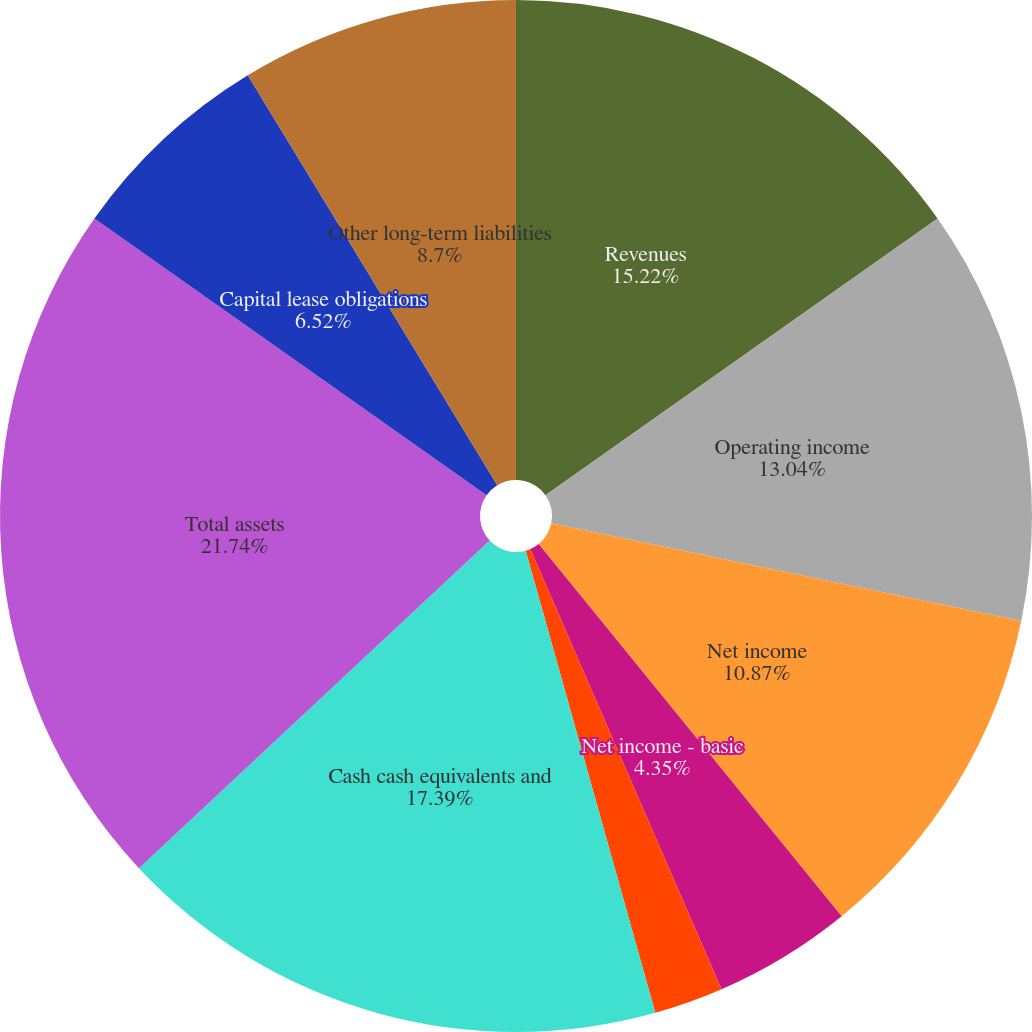Convert chart. <chart><loc_0><loc_0><loc_500><loc_500><pie_chart><fcel>Revenues<fcel>Operating income<fcel>Net income<fcel>Net income - basic<fcel>Net income - diluted<fcel>Dividends announced<fcel>Cash cash equivalents and<fcel>Total assets<fcel>Capital lease obligations<fcel>Other long-term liabilities<nl><fcel>15.22%<fcel>13.04%<fcel>10.87%<fcel>4.35%<fcel>2.17%<fcel>0.0%<fcel>17.39%<fcel>21.74%<fcel>6.52%<fcel>8.7%<nl></chart> 